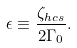Convert formula to latex. <formula><loc_0><loc_0><loc_500><loc_500>\epsilon \equiv \frac { \zeta _ { h c s } } { 2 \Gamma _ { 0 } } .</formula> 